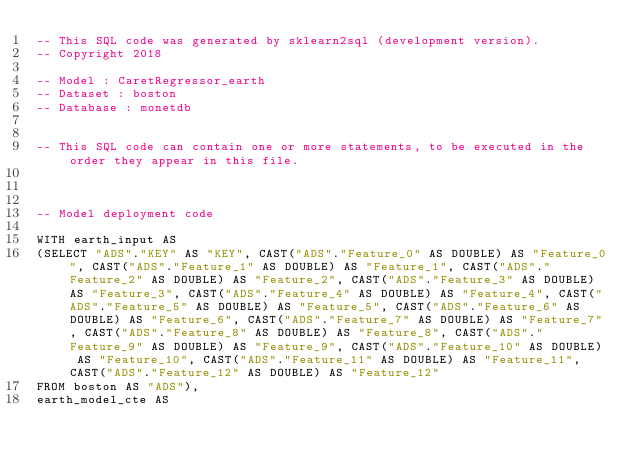<code> <loc_0><loc_0><loc_500><loc_500><_SQL_>-- This SQL code was generated by sklearn2sql (development version).
-- Copyright 2018

-- Model : CaretRegressor_earth
-- Dataset : boston
-- Database : monetdb


-- This SQL code can contain one or more statements, to be executed in the order they appear in this file.



-- Model deployment code

WITH earth_input AS 
(SELECT "ADS"."KEY" AS "KEY", CAST("ADS"."Feature_0" AS DOUBLE) AS "Feature_0", CAST("ADS"."Feature_1" AS DOUBLE) AS "Feature_1", CAST("ADS"."Feature_2" AS DOUBLE) AS "Feature_2", CAST("ADS"."Feature_3" AS DOUBLE) AS "Feature_3", CAST("ADS"."Feature_4" AS DOUBLE) AS "Feature_4", CAST("ADS"."Feature_5" AS DOUBLE) AS "Feature_5", CAST("ADS"."Feature_6" AS DOUBLE) AS "Feature_6", CAST("ADS"."Feature_7" AS DOUBLE) AS "Feature_7", CAST("ADS"."Feature_8" AS DOUBLE) AS "Feature_8", CAST("ADS"."Feature_9" AS DOUBLE) AS "Feature_9", CAST("ADS"."Feature_10" AS DOUBLE) AS "Feature_10", CAST("ADS"."Feature_11" AS DOUBLE) AS "Feature_11", CAST("ADS"."Feature_12" AS DOUBLE) AS "Feature_12" 
FROM boston AS "ADS"), 
earth_model_cte AS </code> 